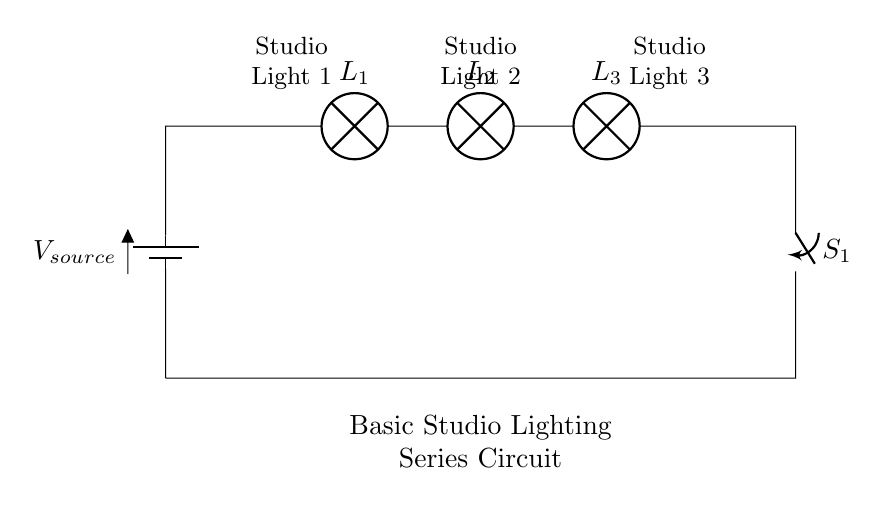What is the total number of bulbs in the circuit? The circuit diagram shows three bulbs connected in series, which can be counted visually.
Answer: Three What type of connection is present in this circuit? The circuit consists of a series connection, as indicated by the arrangement of the components, where each bulb is connected end to end.
Answer: Series What is the function of the switch in this circuit? The switch is used to control the flow of electricity through the circuit, allowing it to be turned on or off.
Answer: Control How many lamps are there between the battery and the switch? There are three lamps (bulbs) connected before reaching the switch in this series configuration.
Answer: Three What happens if one bulb burns out in this circuit? In a series circuit, if one bulb burns out, it breaks the circuit, causing all bulbs to go off due to the continuous path requirement.
Answer: All go off What is the voltage source of the circuit? The circuit shows a single voltage source symbol labeled as V subscript source, indicating that it powers the entire circuit.
Answer: V source 